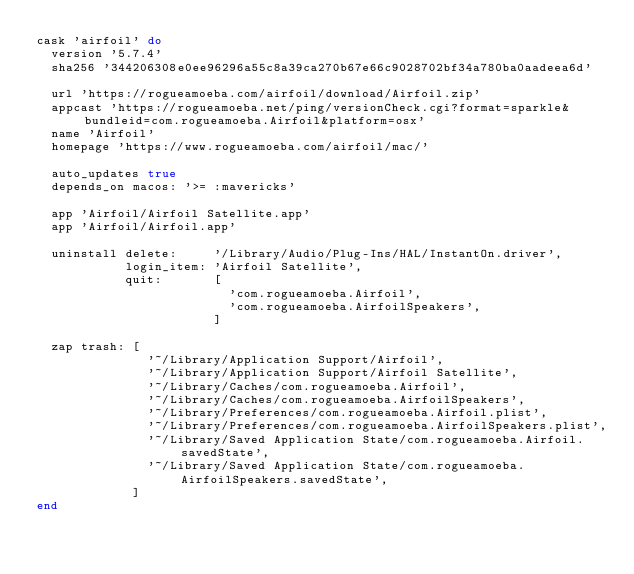<code> <loc_0><loc_0><loc_500><loc_500><_Ruby_>cask 'airfoil' do
  version '5.7.4'
  sha256 '344206308e0ee96296a55c8a39ca270b67e66c9028702bf34a780ba0aadeea6d'

  url 'https://rogueamoeba.com/airfoil/download/Airfoil.zip'
  appcast 'https://rogueamoeba.net/ping/versionCheck.cgi?format=sparkle&bundleid=com.rogueamoeba.Airfoil&platform=osx'
  name 'Airfoil'
  homepage 'https://www.rogueamoeba.com/airfoil/mac/'

  auto_updates true
  depends_on macos: '>= :mavericks'

  app 'Airfoil/Airfoil Satellite.app'
  app 'Airfoil/Airfoil.app'

  uninstall delete:     '/Library/Audio/Plug-Ins/HAL/InstantOn.driver',
            login_item: 'Airfoil Satellite',
            quit:       [
                          'com.rogueamoeba.Airfoil',
                          'com.rogueamoeba.AirfoilSpeakers',
                        ]

  zap trash: [
               '~/Library/Application Support/Airfoil',
               '~/Library/Application Support/Airfoil Satellite',
               '~/Library/Caches/com.rogueamoeba.Airfoil',
               '~/Library/Caches/com.rogueamoeba.AirfoilSpeakers',
               '~/Library/Preferences/com.rogueamoeba.Airfoil.plist',
               '~/Library/Preferences/com.rogueamoeba.AirfoilSpeakers.plist',
               '~/Library/Saved Application State/com.rogueamoeba.Airfoil.savedState',
               '~/Library/Saved Application State/com.rogueamoeba.AirfoilSpeakers.savedState',
             ]
end
</code> 